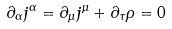Convert formula to latex. <formula><loc_0><loc_0><loc_500><loc_500>\partial _ { \alpha } j ^ { \alpha } = \partial _ { \mu } j ^ { \mu } + \partial _ { \tau } \rho = 0</formula> 